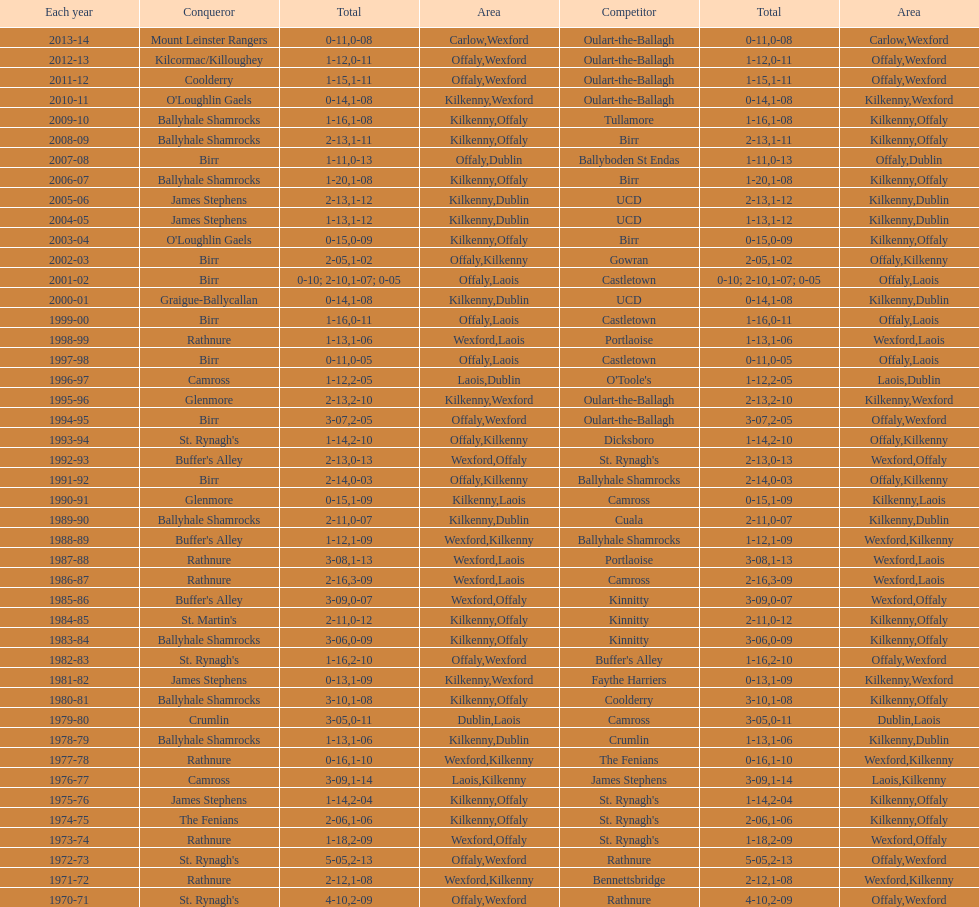James stephens won in 1976-76. who won three years before that? St. Rynagh's. 